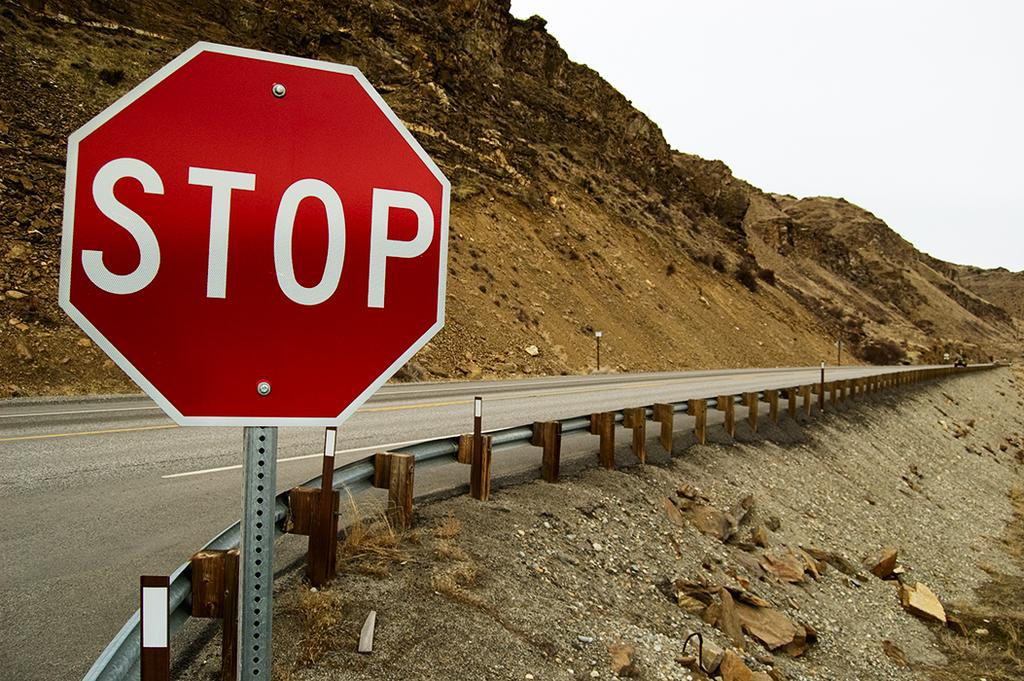<image>
Summarize the visual content of the image. A sign that reads "stop" placed along a roadside next to a steep hill. 